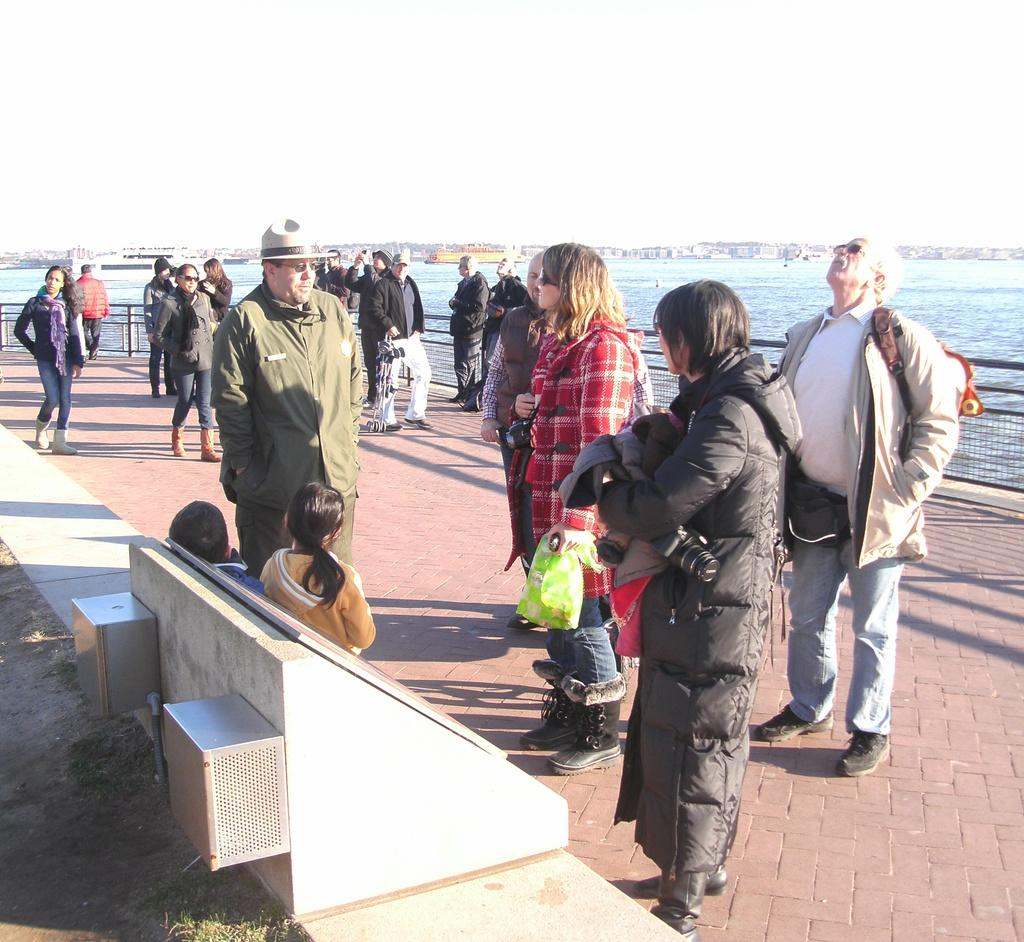What is located in the foreground of the image? There are people in the foreground of the image. What can be seen in the background of the image? There are buildings, water, people, and the sky visible in the background of the image. Can you describe the setting of the image? The image features people in the foreground, with buildings, water, and the sky in the background. What type of grass is being used as a substitute for trousers in the image? There is no grass or trousers present in the image. What appliance is being used by the people in the image? There is no appliance visible in the image. 